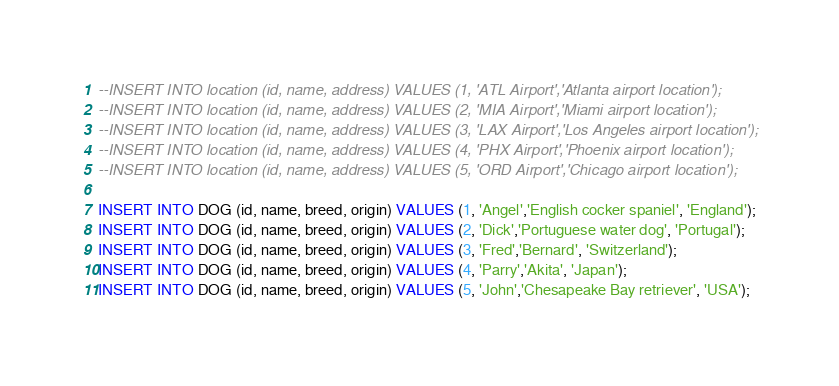Convert code to text. <code><loc_0><loc_0><loc_500><loc_500><_SQL_>--INSERT INTO location (id, name, address) VALUES (1, 'ATL Airport','Atlanta airport location');
--INSERT INTO location (id, name, address) VALUES (2, 'MIA Airport','Miami airport location');
--INSERT INTO location (id, name, address) VALUES (3, 'LAX Airport','Los Angeles airport location');
--INSERT INTO location (id, name, address) VALUES (4, 'PHX Airport','Phoenix airport location');
--INSERT INTO location (id, name, address) VALUES (5, 'ORD Airport','Chicago airport location');

INSERT INTO DOG (id, name, breed, origin) VALUES (1, 'Angel','English cocker spaniel', 'England');
INSERT INTO DOG (id, name, breed, origin) VALUES (2, 'Dick','Portuguese water dog', 'Portugal');
INSERT INTO DOG (id, name, breed, origin) VALUES (3, 'Fred','Bernard', 'Switzerland');
INSERT INTO DOG (id, name, breed, origin) VALUES (4, 'Parry','Akita', 'Japan');
INSERT INTO DOG (id, name, breed, origin) VALUES (5, 'John','Chesapeake Bay retriever', 'USA');

</code> 